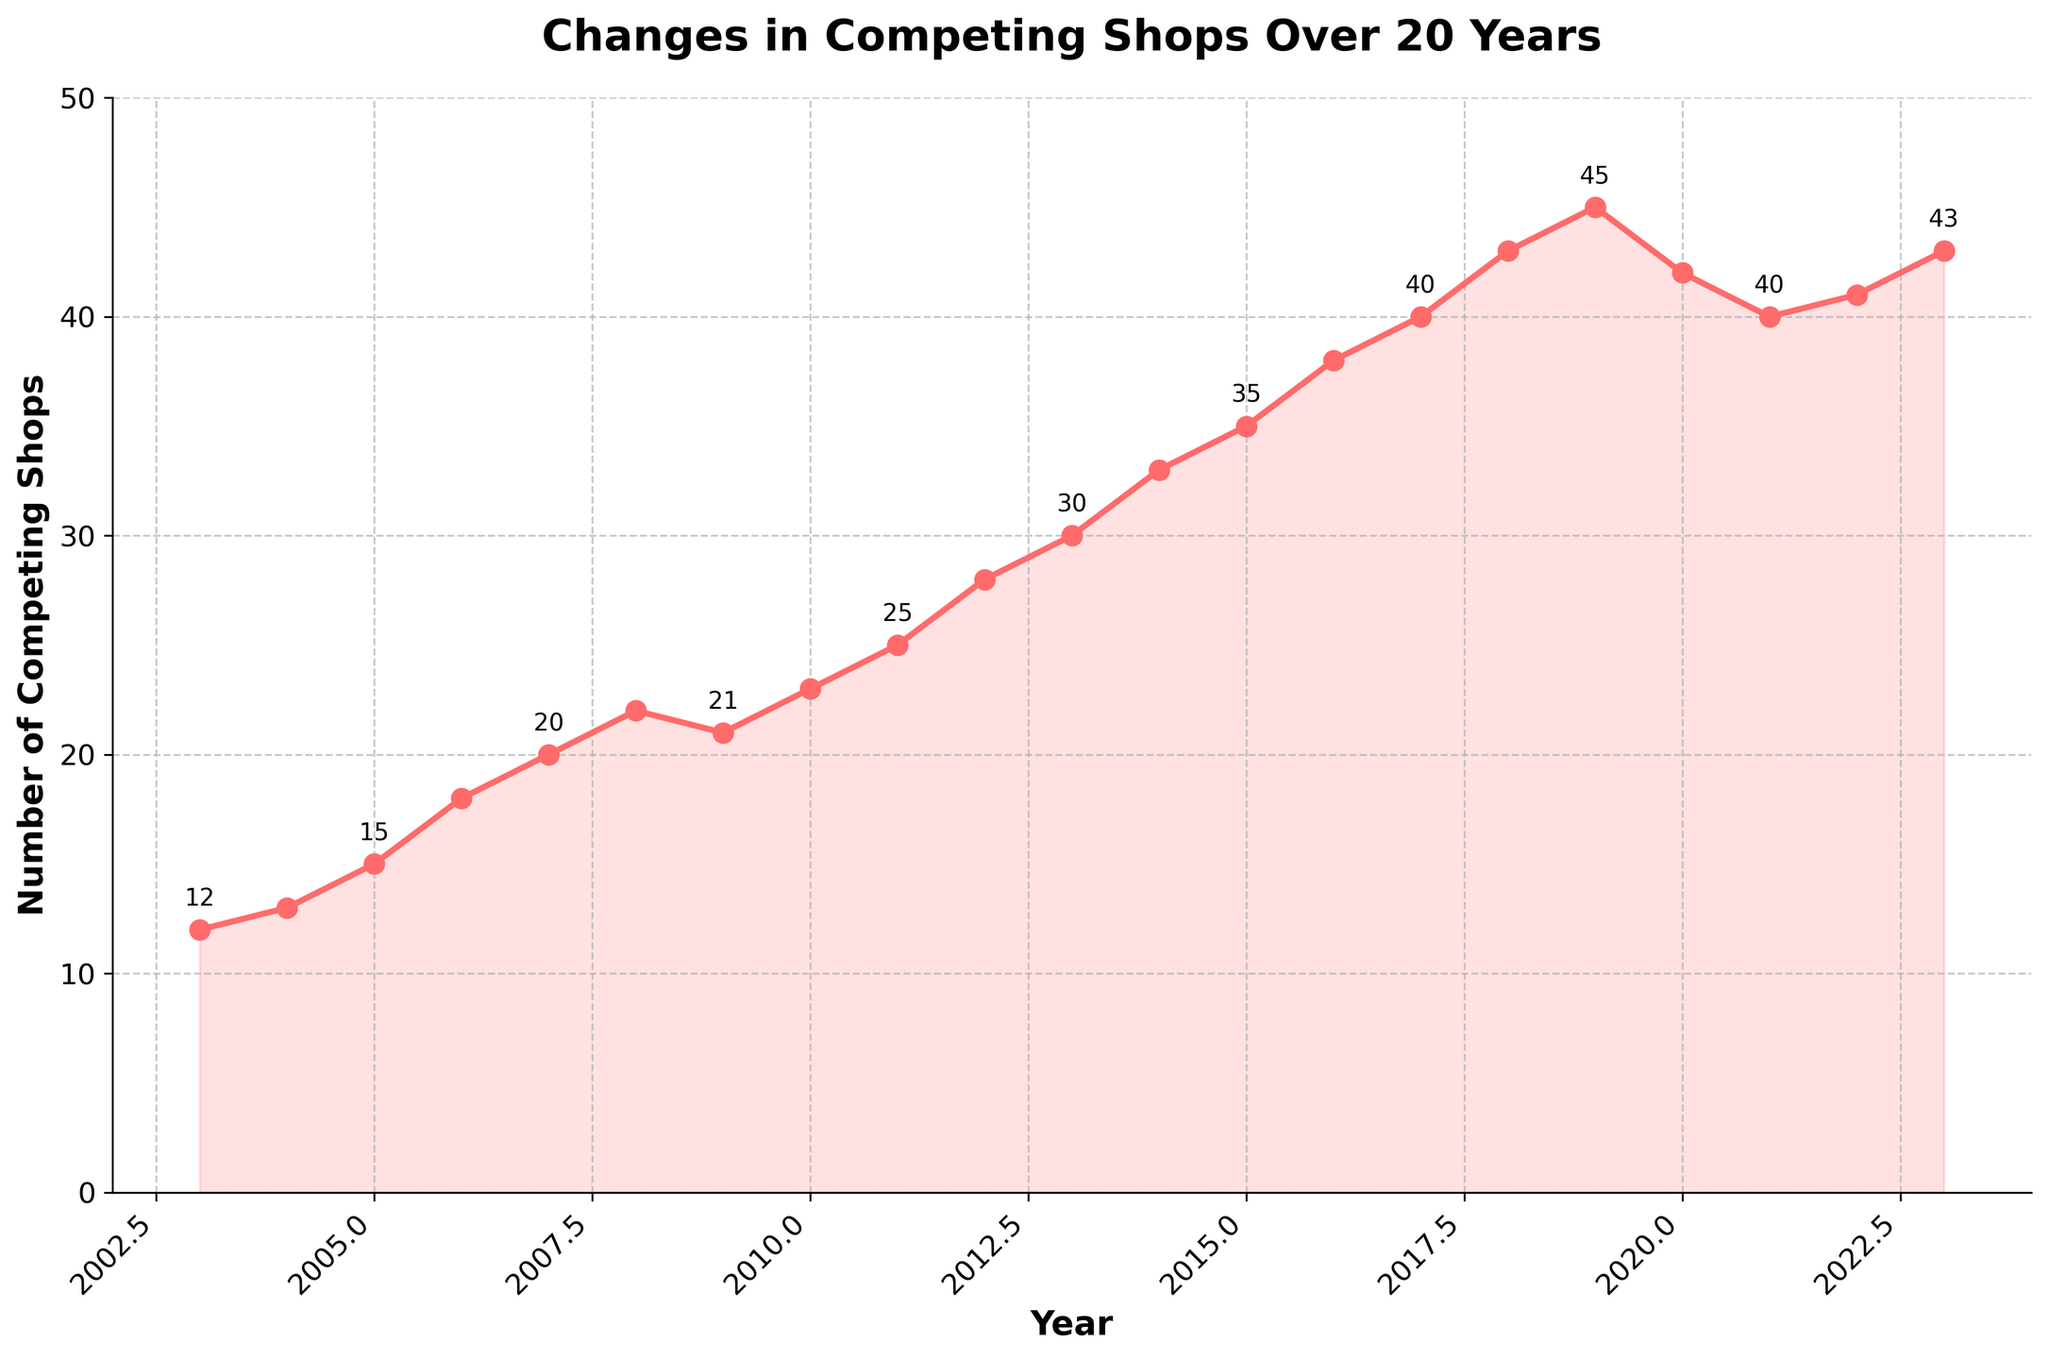What was the number of competing shops in 2008? Referring to the figure, find the year 2008 on the x-axis and read the corresponding value on the y-axis, which represents the number of competing shops.
Answer: 22 In which year did the number of competing shops first reach 40? Look at the line in the figure and identify the first point where the y-axis value reaches 40. Find the corresponding year on the x-axis.
Answer: 2017 Between which years did the number of competing shops decrease? Observe the trend of the line in the figure and identify any downward slopes, indicating a decrease. Check the x-axis to find the corresponding years.
Answer: 2019-2020 and 2020-2021 Which year shows the maximum increase in the number of competing shops compared to the previous year? Look at the figure to identify the year-to-year increases and determine which year has the largest increase by comparing the rise in y-axis values.
Answer: 2018 How many times did the number of competing shops increase by exactly 3 from one year to the next? Check the figure for changes in the number of shops and count the instances where the increase from one year to the next is exactly 3.
Answer: 4 times (2006-2007, 2011-2012, 2013-2014, 2016-2017) What was the lowest number of competing shops recorded? Refer to the figure and find the lowest point on the y-axis to identify the lowest number of competing shops.
Answer: 12 